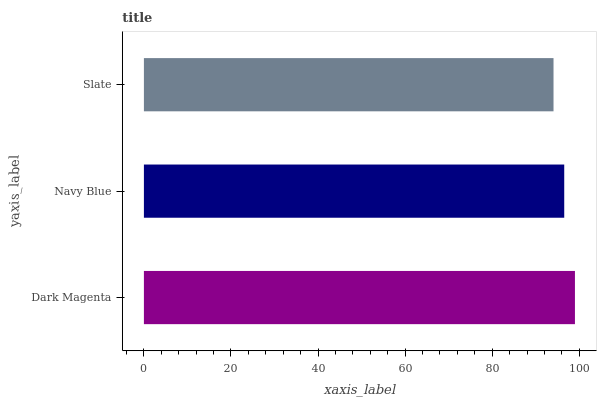Is Slate the minimum?
Answer yes or no. Yes. Is Dark Magenta the maximum?
Answer yes or no. Yes. Is Navy Blue the minimum?
Answer yes or no. No. Is Navy Blue the maximum?
Answer yes or no. No. Is Dark Magenta greater than Navy Blue?
Answer yes or no. Yes. Is Navy Blue less than Dark Magenta?
Answer yes or no. Yes. Is Navy Blue greater than Dark Magenta?
Answer yes or no. No. Is Dark Magenta less than Navy Blue?
Answer yes or no. No. Is Navy Blue the high median?
Answer yes or no. Yes. Is Navy Blue the low median?
Answer yes or no. Yes. Is Dark Magenta the high median?
Answer yes or no. No. Is Dark Magenta the low median?
Answer yes or no. No. 